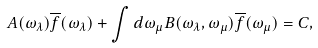Convert formula to latex. <formula><loc_0><loc_0><loc_500><loc_500>A ( \omega _ { \lambda } ) \overline { f } ( \omega _ { \lambda } ) + \int d \omega _ { \mu } B ( \omega _ { \lambda } , \omega _ { \mu } ) \overline { f } ( \omega _ { \mu } ) = C ,</formula> 